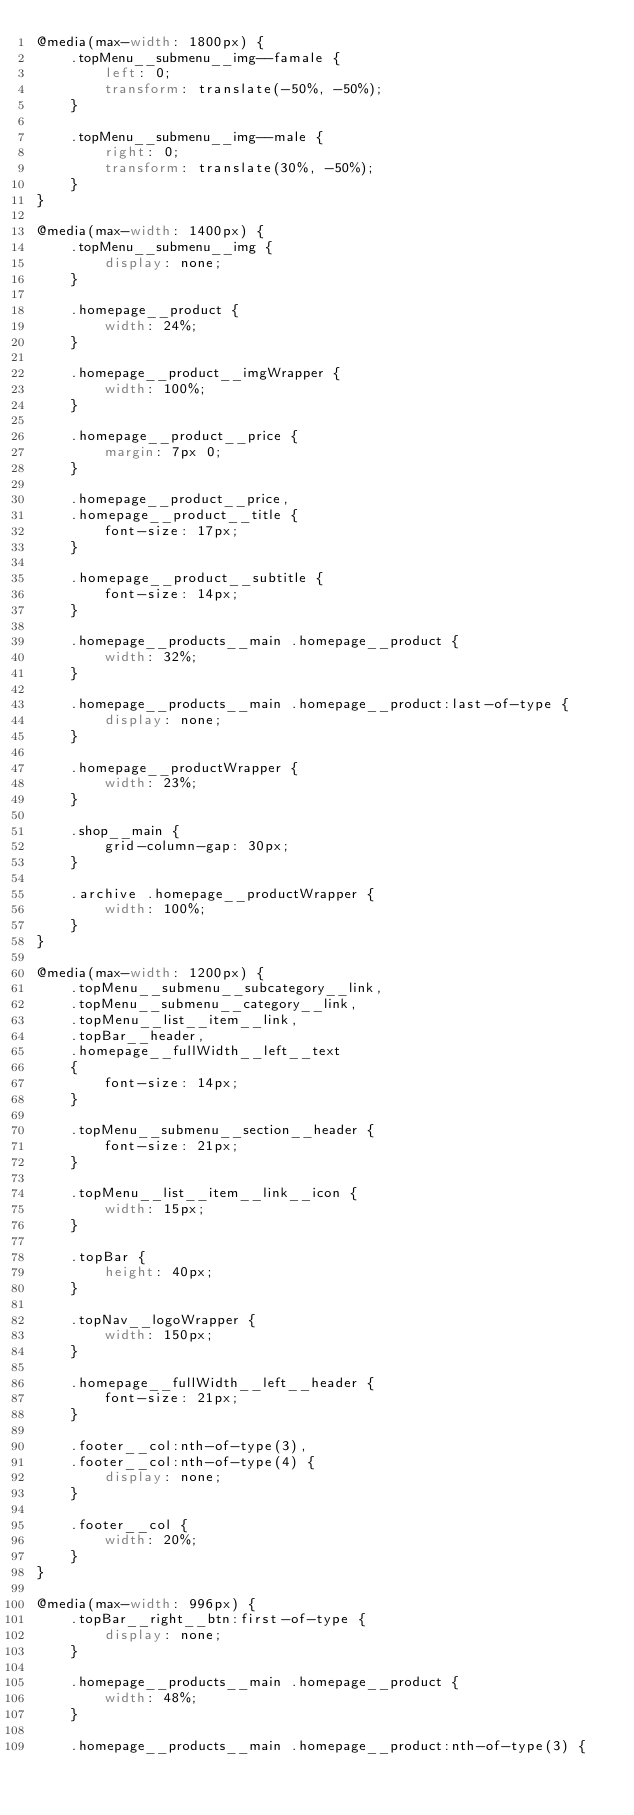<code> <loc_0><loc_0><loc_500><loc_500><_CSS_>@media(max-width: 1800px) {
    .topMenu__submenu__img--famale {
        left: 0;
        transform: translate(-50%, -50%);
    }

    .topMenu__submenu__img--male {
        right: 0;
        transform: translate(30%, -50%);
    }
}

@media(max-width: 1400px) {
    .topMenu__submenu__img {
        display: none;
    }

    .homepage__product {
        width: 24%;
    }

    .homepage__product__imgWrapper {
        width: 100%;
    }

    .homepage__product__price {
        margin: 7px 0;
    }

    .homepage__product__price,
    .homepage__product__title {
        font-size: 17px;
    }

    .homepage__product__subtitle {
        font-size: 14px;
    }

    .homepage__products__main .homepage__product {
        width: 32%;
    }

    .homepage__products__main .homepage__product:last-of-type {
        display: none;
    }

    .homepage__productWrapper {
        width: 23%;
    }

    .shop__main {
        grid-column-gap: 30px;
    }

    .archive .homepage__productWrapper {
        width: 100%;
    }
}

@media(max-width: 1200px) {
    .topMenu__submenu__subcategory__link,
    .topMenu__submenu__category__link,
    .topMenu__list__item__link,
    .topBar__header,
    .homepage__fullWidth__left__text
    {
        font-size: 14px;
    }

    .topMenu__submenu__section__header {
        font-size: 21px;
    }

    .topMenu__list__item__link__icon {
        width: 15px;
    }

    .topBar {
        height: 40px;
    }

    .topNav__logoWrapper {
        width: 150px;
    }

    .homepage__fullWidth__left__header {
        font-size: 21px;
    }

    .footer__col:nth-of-type(3),
    .footer__col:nth-of-type(4) {
        display: none;
    }

    .footer__col {
        width: 20%;
    }
}

@media(max-width: 996px) {
    .topBar__right__btn:first-of-type {
        display: none;
    }

    .homepage__products__main .homepage__product {
        width: 48%;
    }

    .homepage__products__main .homepage__product:nth-of-type(3) {</code> 